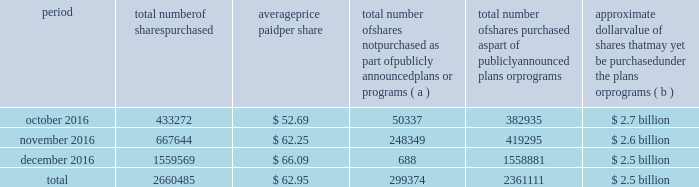Table of contents the table discloses purchases of shares of our common stock made by us or on our behalf during the fourth quarter of 2016 .
Period total number of shares purchased average price paid per share total number of shares not purchased as part of publicly announced plans or programs ( a ) total number of shares purchased as part of publicly announced plans or programs approximate dollar value of shares that may yet be purchased under the plans or programs ( b ) .
( a ) the shares reported in this column represent purchases settled in the fourth quarter of 2016 relating to ( i ) our purchases of shares in open-market transactions to meet our obligations under stock-based compensation plans , and ( ii ) our purchases of shares from our employees and non-employee directors in connection with the exercise of stock options , the vesting of restricted stock , and other stock compensation transactions in accordance with the terms of our stock-based compensation plans .
( b ) on july 13 , 2015 , we announced that our board of directors authorized our purchase of up to $ 2.5 billion of our outstanding common stock .
This authorization has no expiration date .
As of december 31 , 2016 , the approximate dollar value of shares that may yet be purchased under the 2015 authorization is $ 40 million .
On september 21 , 2016 , we announced that our board of directors authorized our purchase of up to an additional $ 2.5 billion of our outstanding common stock with no expiration date .
As of december 31 , 2016 , no purchases have been made under the 2016 authorization. .
For the quarter ended december 31 , 2016 what was the percent of the total number of shares purchased in november? 
Computations: (667644 / 2660485)
Answer: 0.25095. 